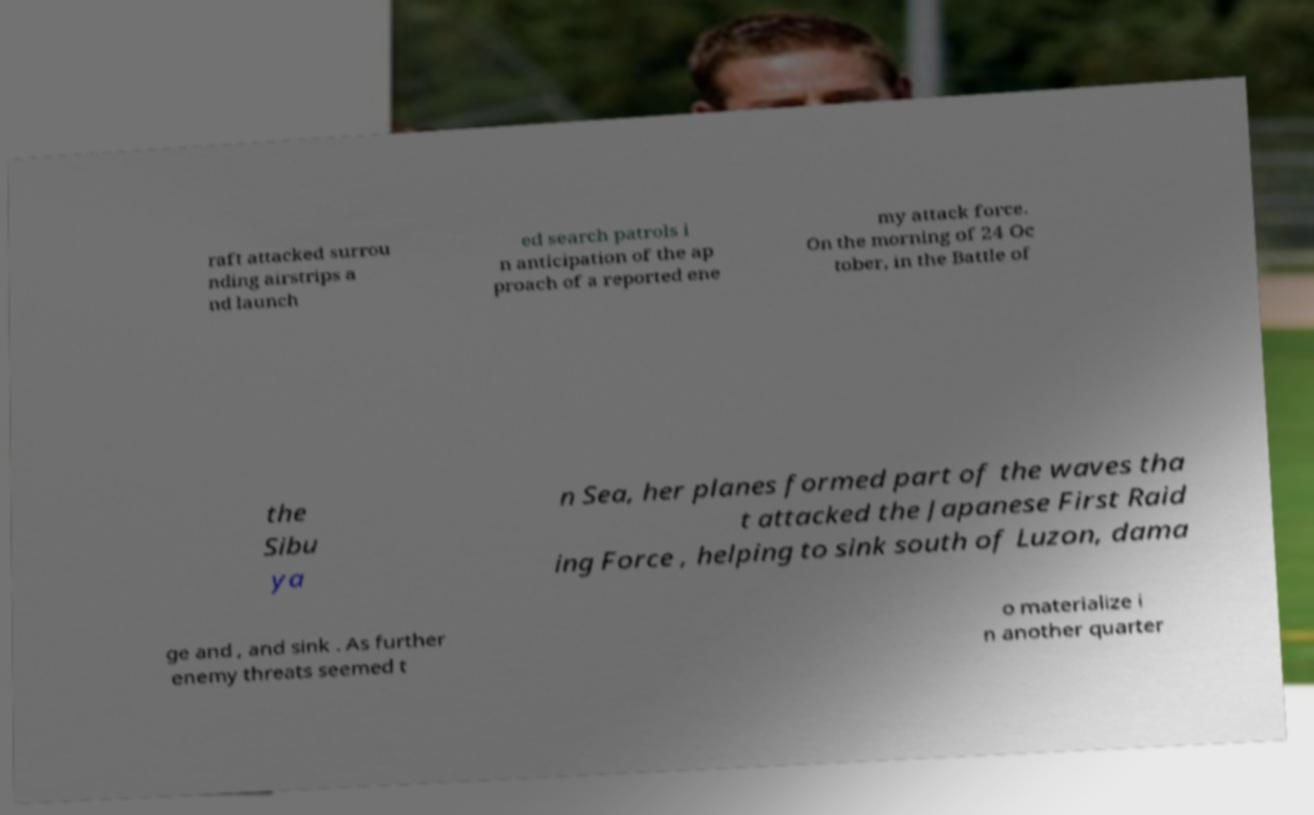What messages or text are displayed in this image? I need them in a readable, typed format. raft attacked surrou nding airstrips a nd launch ed search patrols i n anticipation of the ap proach of a reported ene my attack force. On the morning of 24 Oc tober, in the Battle of the Sibu ya n Sea, her planes formed part of the waves tha t attacked the Japanese First Raid ing Force , helping to sink south of Luzon, dama ge and , and sink . As further enemy threats seemed t o materialize i n another quarter 